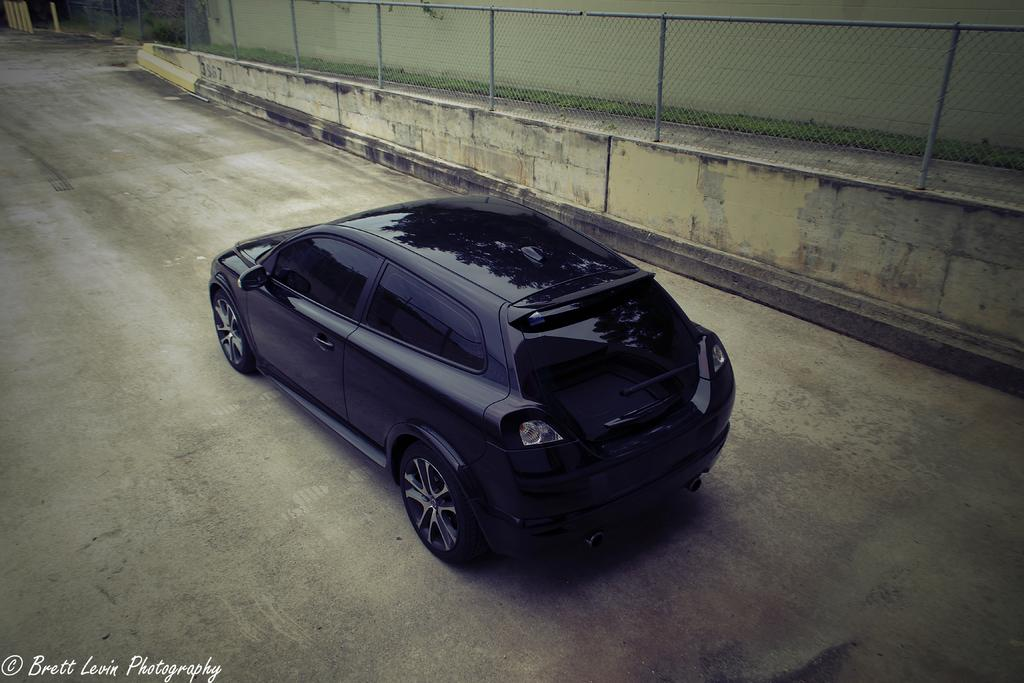What is the main subject of the picture? The main subject of the picture is a black color car. What is the car doing in the image? The car is moving on the road. What can be seen in the background of the image? There is a wall and a fence in the background of the image. What is visible at the bottom of the picture? The road is visible at the bottom of the picture. What type of poison is being used to power the tent in the image? There is no tent, poison, or power source present in the image. 